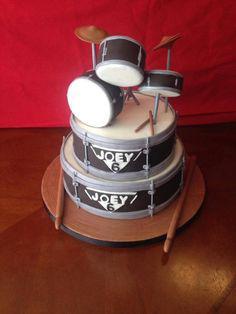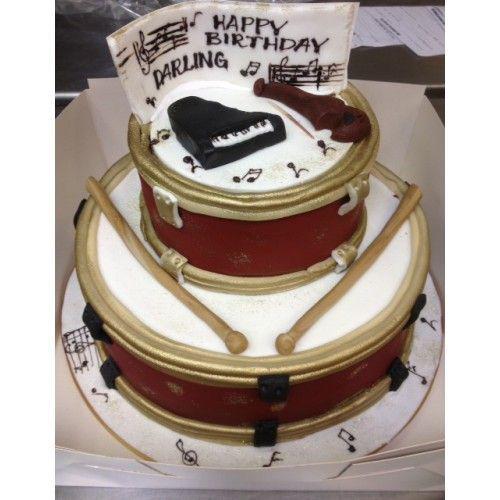The first image is the image on the left, the second image is the image on the right. Given the left and right images, does the statement "Both cakes are tiered." hold true? Answer yes or no. Yes. The first image is the image on the left, the second image is the image on the right. Given the left and right images, does the statement "One cake features a drum kit on the top, and the other cake features drum sticks on top of the base layer of the cake." hold true? Answer yes or no. Yes. 